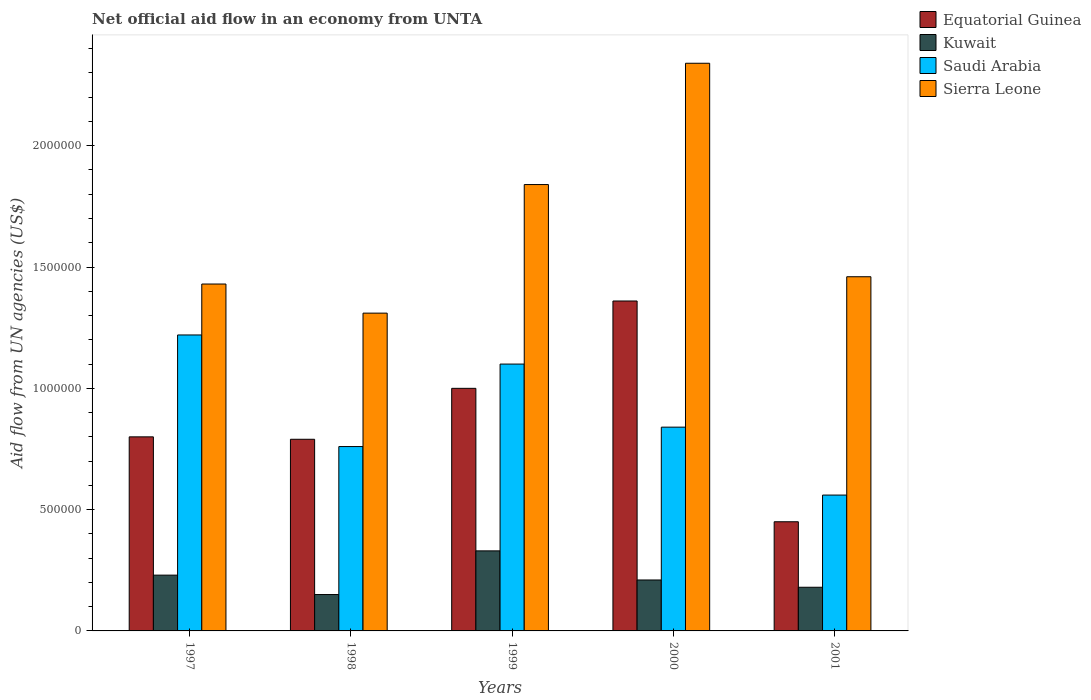How many groups of bars are there?
Ensure brevity in your answer.  5. Are the number of bars per tick equal to the number of legend labels?
Your answer should be very brief. Yes. How many bars are there on the 2nd tick from the left?
Give a very brief answer. 4. How many bars are there on the 2nd tick from the right?
Your response must be concise. 4. What is the label of the 5th group of bars from the left?
Your answer should be compact. 2001. In how many cases, is the number of bars for a given year not equal to the number of legend labels?
Keep it short and to the point. 0. Across all years, what is the maximum net official aid flow in Sierra Leone?
Give a very brief answer. 2.34e+06. Across all years, what is the minimum net official aid flow in Kuwait?
Provide a short and direct response. 1.50e+05. In which year was the net official aid flow in Sierra Leone maximum?
Keep it short and to the point. 2000. What is the total net official aid flow in Sierra Leone in the graph?
Keep it short and to the point. 8.38e+06. What is the difference between the net official aid flow in Sierra Leone in 1997 and that in 1999?
Offer a terse response. -4.10e+05. What is the difference between the net official aid flow in Sierra Leone in 1997 and the net official aid flow in Kuwait in 2001?
Ensure brevity in your answer.  1.25e+06. What is the ratio of the net official aid flow in Equatorial Guinea in 1997 to that in 1999?
Offer a terse response. 0.8. Is the difference between the net official aid flow in Sierra Leone in 1997 and 2000 greater than the difference between the net official aid flow in Saudi Arabia in 1997 and 2000?
Your response must be concise. No. What is the difference between the highest and the second highest net official aid flow in Equatorial Guinea?
Provide a short and direct response. 3.60e+05. What is the difference between the highest and the lowest net official aid flow in Sierra Leone?
Provide a succinct answer. 1.03e+06. In how many years, is the net official aid flow in Saudi Arabia greater than the average net official aid flow in Saudi Arabia taken over all years?
Keep it short and to the point. 2. What does the 3rd bar from the left in 2000 represents?
Your answer should be very brief. Saudi Arabia. What does the 2nd bar from the right in 2001 represents?
Make the answer very short. Saudi Arabia. Is it the case that in every year, the sum of the net official aid flow in Kuwait and net official aid flow in Sierra Leone is greater than the net official aid flow in Saudi Arabia?
Offer a very short reply. Yes. Where does the legend appear in the graph?
Your answer should be compact. Top right. How are the legend labels stacked?
Provide a succinct answer. Vertical. What is the title of the graph?
Provide a short and direct response. Net official aid flow in an economy from UNTA. Does "Other small states" appear as one of the legend labels in the graph?
Give a very brief answer. No. What is the label or title of the X-axis?
Make the answer very short. Years. What is the label or title of the Y-axis?
Make the answer very short. Aid flow from UN agencies (US$). What is the Aid flow from UN agencies (US$) in Equatorial Guinea in 1997?
Keep it short and to the point. 8.00e+05. What is the Aid flow from UN agencies (US$) in Saudi Arabia in 1997?
Give a very brief answer. 1.22e+06. What is the Aid flow from UN agencies (US$) of Sierra Leone in 1997?
Offer a terse response. 1.43e+06. What is the Aid flow from UN agencies (US$) in Equatorial Guinea in 1998?
Provide a succinct answer. 7.90e+05. What is the Aid flow from UN agencies (US$) in Saudi Arabia in 1998?
Your answer should be compact. 7.60e+05. What is the Aid flow from UN agencies (US$) of Sierra Leone in 1998?
Give a very brief answer. 1.31e+06. What is the Aid flow from UN agencies (US$) in Equatorial Guinea in 1999?
Your answer should be compact. 1.00e+06. What is the Aid flow from UN agencies (US$) of Saudi Arabia in 1999?
Your answer should be compact. 1.10e+06. What is the Aid flow from UN agencies (US$) in Sierra Leone in 1999?
Offer a terse response. 1.84e+06. What is the Aid flow from UN agencies (US$) in Equatorial Guinea in 2000?
Offer a very short reply. 1.36e+06. What is the Aid flow from UN agencies (US$) of Kuwait in 2000?
Make the answer very short. 2.10e+05. What is the Aid flow from UN agencies (US$) in Saudi Arabia in 2000?
Your response must be concise. 8.40e+05. What is the Aid flow from UN agencies (US$) in Sierra Leone in 2000?
Ensure brevity in your answer.  2.34e+06. What is the Aid flow from UN agencies (US$) of Kuwait in 2001?
Your response must be concise. 1.80e+05. What is the Aid flow from UN agencies (US$) of Saudi Arabia in 2001?
Provide a succinct answer. 5.60e+05. What is the Aid flow from UN agencies (US$) of Sierra Leone in 2001?
Offer a terse response. 1.46e+06. Across all years, what is the maximum Aid flow from UN agencies (US$) in Equatorial Guinea?
Make the answer very short. 1.36e+06. Across all years, what is the maximum Aid flow from UN agencies (US$) of Saudi Arabia?
Provide a short and direct response. 1.22e+06. Across all years, what is the maximum Aid flow from UN agencies (US$) in Sierra Leone?
Your answer should be compact. 2.34e+06. Across all years, what is the minimum Aid flow from UN agencies (US$) of Equatorial Guinea?
Your response must be concise. 4.50e+05. Across all years, what is the minimum Aid flow from UN agencies (US$) in Kuwait?
Your response must be concise. 1.50e+05. Across all years, what is the minimum Aid flow from UN agencies (US$) in Saudi Arabia?
Keep it short and to the point. 5.60e+05. Across all years, what is the minimum Aid flow from UN agencies (US$) of Sierra Leone?
Make the answer very short. 1.31e+06. What is the total Aid flow from UN agencies (US$) of Equatorial Guinea in the graph?
Offer a terse response. 4.40e+06. What is the total Aid flow from UN agencies (US$) of Kuwait in the graph?
Provide a short and direct response. 1.10e+06. What is the total Aid flow from UN agencies (US$) of Saudi Arabia in the graph?
Your answer should be very brief. 4.48e+06. What is the total Aid flow from UN agencies (US$) of Sierra Leone in the graph?
Ensure brevity in your answer.  8.38e+06. What is the difference between the Aid flow from UN agencies (US$) of Kuwait in 1997 and that in 1998?
Your response must be concise. 8.00e+04. What is the difference between the Aid flow from UN agencies (US$) in Saudi Arabia in 1997 and that in 1998?
Your answer should be compact. 4.60e+05. What is the difference between the Aid flow from UN agencies (US$) in Sierra Leone in 1997 and that in 1998?
Ensure brevity in your answer.  1.20e+05. What is the difference between the Aid flow from UN agencies (US$) in Equatorial Guinea in 1997 and that in 1999?
Provide a short and direct response. -2.00e+05. What is the difference between the Aid flow from UN agencies (US$) of Kuwait in 1997 and that in 1999?
Ensure brevity in your answer.  -1.00e+05. What is the difference between the Aid flow from UN agencies (US$) of Saudi Arabia in 1997 and that in 1999?
Give a very brief answer. 1.20e+05. What is the difference between the Aid flow from UN agencies (US$) of Sierra Leone in 1997 and that in 1999?
Your response must be concise. -4.10e+05. What is the difference between the Aid flow from UN agencies (US$) in Equatorial Guinea in 1997 and that in 2000?
Offer a terse response. -5.60e+05. What is the difference between the Aid flow from UN agencies (US$) in Sierra Leone in 1997 and that in 2000?
Your answer should be very brief. -9.10e+05. What is the difference between the Aid flow from UN agencies (US$) of Equatorial Guinea in 1997 and that in 2001?
Ensure brevity in your answer.  3.50e+05. What is the difference between the Aid flow from UN agencies (US$) in Kuwait in 1997 and that in 2001?
Make the answer very short. 5.00e+04. What is the difference between the Aid flow from UN agencies (US$) of Saudi Arabia in 1997 and that in 2001?
Offer a terse response. 6.60e+05. What is the difference between the Aid flow from UN agencies (US$) of Kuwait in 1998 and that in 1999?
Your response must be concise. -1.80e+05. What is the difference between the Aid flow from UN agencies (US$) in Saudi Arabia in 1998 and that in 1999?
Your answer should be compact. -3.40e+05. What is the difference between the Aid flow from UN agencies (US$) of Sierra Leone in 1998 and that in 1999?
Offer a very short reply. -5.30e+05. What is the difference between the Aid flow from UN agencies (US$) in Equatorial Guinea in 1998 and that in 2000?
Provide a succinct answer. -5.70e+05. What is the difference between the Aid flow from UN agencies (US$) of Kuwait in 1998 and that in 2000?
Your answer should be compact. -6.00e+04. What is the difference between the Aid flow from UN agencies (US$) in Saudi Arabia in 1998 and that in 2000?
Give a very brief answer. -8.00e+04. What is the difference between the Aid flow from UN agencies (US$) of Sierra Leone in 1998 and that in 2000?
Offer a very short reply. -1.03e+06. What is the difference between the Aid flow from UN agencies (US$) of Equatorial Guinea in 1998 and that in 2001?
Your answer should be compact. 3.40e+05. What is the difference between the Aid flow from UN agencies (US$) in Kuwait in 1998 and that in 2001?
Give a very brief answer. -3.00e+04. What is the difference between the Aid flow from UN agencies (US$) in Saudi Arabia in 1998 and that in 2001?
Give a very brief answer. 2.00e+05. What is the difference between the Aid flow from UN agencies (US$) in Equatorial Guinea in 1999 and that in 2000?
Keep it short and to the point. -3.60e+05. What is the difference between the Aid flow from UN agencies (US$) in Saudi Arabia in 1999 and that in 2000?
Make the answer very short. 2.60e+05. What is the difference between the Aid flow from UN agencies (US$) of Sierra Leone in 1999 and that in 2000?
Keep it short and to the point. -5.00e+05. What is the difference between the Aid flow from UN agencies (US$) of Saudi Arabia in 1999 and that in 2001?
Offer a very short reply. 5.40e+05. What is the difference between the Aid flow from UN agencies (US$) of Equatorial Guinea in 2000 and that in 2001?
Ensure brevity in your answer.  9.10e+05. What is the difference between the Aid flow from UN agencies (US$) in Sierra Leone in 2000 and that in 2001?
Give a very brief answer. 8.80e+05. What is the difference between the Aid flow from UN agencies (US$) of Equatorial Guinea in 1997 and the Aid flow from UN agencies (US$) of Kuwait in 1998?
Keep it short and to the point. 6.50e+05. What is the difference between the Aid flow from UN agencies (US$) of Equatorial Guinea in 1997 and the Aid flow from UN agencies (US$) of Sierra Leone in 1998?
Ensure brevity in your answer.  -5.10e+05. What is the difference between the Aid flow from UN agencies (US$) of Kuwait in 1997 and the Aid flow from UN agencies (US$) of Saudi Arabia in 1998?
Offer a terse response. -5.30e+05. What is the difference between the Aid flow from UN agencies (US$) of Kuwait in 1997 and the Aid flow from UN agencies (US$) of Sierra Leone in 1998?
Provide a short and direct response. -1.08e+06. What is the difference between the Aid flow from UN agencies (US$) of Saudi Arabia in 1997 and the Aid flow from UN agencies (US$) of Sierra Leone in 1998?
Your answer should be compact. -9.00e+04. What is the difference between the Aid flow from UN agencies (US$) of Equatorial Guinea in 1997 and the Aid flow from UN agencies (US$) of Kuwait in 1999?
Make the answer very short. 4.70e+05. What is the difference between the Aid flow from UN agencies (US$) in Equatorial Guinea in 1997 and the Aid flow from UN agencies (US$) in Saudi Arabia in 1999?
Provide a succinct answer. -3.00e+05. What is the difference between the Aid flow from UN agencies (US$) of Equatorial Guinea in 1997 and the Aid flow from UN agencies (US$) of Sierra Leone in 1999?
Provide a succinct answer. -1.04e+06. What is the difference between the Aid flow from UN agencies (US$) in Kuwait in 1997 and the Aid flow from UN agencies (US$) in Saudi Arabia in 1999?
Offer a very short reply. -8.70e+05. What is the difference between the Aid flow from UN agencies (US$) in Kuwait in 1997 and the Aid flow from UN agencies (US$) in Sierra Leone in 1999?
Provide a short and direct response. -1.61e+06. What is the difference between the Aid flow from UN agencies (US$) of Saudi Arabia in 1997 and the Aid flow from UN agencies (US$) of Sierra Leone in 1999?
Offer a very short reply. -6.20e+05. What is the difference between the Aid flow from UN agencies (US$) of Equatorial Guinea in 1997 and the Aid flow from UN agencies (US$) of Kuwait in 2000?
Offer a very short reply. 5.90e+05. What is the difference between the Aid flow from UN agencies (US$) in Equatorial Guinea in 1997 and the Aid flow from UN agencies (US$) in Saudi Arabia in 2000?
Provide a short and direct response. -4.00e+04. What is the difference between the Aid flow from UN agencies (US$) in Equatorial Guinea in 1997 and the Aid flow from UN agencies (US$) in Sierra Leone in 2000?
Your answer should be very brief. -1.54e+06. What is the difference between the Aid flow from UN agencies (US$) of Kuwait in 1997 and the Aid flow from UN agencies (US$) of Saudi Arabia in 2000?
Ensure brevity in your answer.  -6.10e+05. What is the difference between the Aid flow from UN agencies (US$) in Kuwait in 1997 and the Aid flow from UN agencies (US$) in Sierra Leone in 2000?
Give a very brief answer. -2.11e+06. What is the difference between the Aid flow from UN agencies (US$) in Saudi Arabia in 1997 and the Aid flow from UN agencies (US$) in Sierra Leone in 2000?
Offer a very short reply. -1.12e+06. What is the difference between the Aid flow from UN agencies (US$) in Equatorial Guinea in 1997 and the Aid flow from UN agencies (US$) in Kuwait in 2001?
Ensure brevity in your answer.  6.20e+05. What is the difference between the Aid flow from UN agencies (US$) of Equatorial Guinea in 1997 and the Aid flow from UN agencies (US$) of Sierra Leone in 2001?
Your answer should be very brief. -6.60e+05. What is the difference between the Aid flow from UN agencies (US$) in Kuwait in 1997 and the Aid flow from UN agencies (US$) in Saudi Arabia in 2001?
Provide a succinct answer. -3.30e+05. What is the difference between the Aid flow from UN agencies (US$) in Kuwait in 1997 and the Aid flow from UN agencies (US$) in Sierra Leone in 2001?
Your response must be concise. -1.23e+06. What is the difference between the Aid flow from UN agencies (US$) of Saudi Arabia in 1997 and the Aid flow from UN agencies (US$) of Sierra Leone in 2001?
Offer a terse response. -2.40e+05. What is the difference between the Aid flow from UN agencies (US$) of Equatorial Guinea in 1998 and the Aid flow from UN agencies (US$) of Saudi Arabia in 1999?
Ensure brevity in your answer.  -3.10e+05. What is the difference between the Aid flow from UN agencies (US$) in Equatorial Guinea in 1998 and the Aid flow from UN agencies (US$) in Sierra Leone in 1999?
Your response must be concise. -1.05e+06. What is the difference between the Aid flow from UN agencies (US$) of Kuwait in 1998 and the Aid flow from UN agencies (US$) of Saudi Arabia in 1999?
Provide a succinct answer. -9.50e+05. What is the difference between the Aid flow from UN agencies (US$) of Kuwait in 1998 and the Aid flow from UN agencies (US$) of Sierra Leone in 1999?
Your answer should be compact. -1.69e+06. What is the difference between the Aid flow from UN agencies (US$) of Saudi Arabia in 1998 and the Aid flow from UN agencies (US$) of Sierra Leone in 1999?
Provide a succinct answer. -1.08e+06. What is the difference between the Aid flow from UN agencies (US$) of Equatorial Guinea in 1998 and the Aid flow from UN agencies (US$) of Kuwait in 2000?
Your answer should be compact. 5.80e+05. What is the difference between the Aid flow from UN agencies (US$) in Equatorial Guinea in 1998 and the Aid flow from UN agencies (US$) in Sierra Leone in 2000?
Ensure brevity in your answer.  -1.55e+06. What is the difference between the Aid flow from UN agencies (US$) of Kuwait in 1998 and the Aid flow from UN agencies (US$) of Saudi Arabia in 2000?
Make the answer very short. -6.90e+05. What is the difference between the Aid flow from UN agencies (US$) in Kuwait in 1998 and the Aid flow from UN agencies (US$) in Sierra Leone in 2000?
Give a very brief answer. -2.19e+06. What is the difference between the Aid flow from UN agencies (US$) in Saudi Arabia in 1998 and the Aid flow from UN agencies (US$) in Sierra Leone in 2000?
Provide a short and direct response. -1.58e+06. What is the difference between the Aid flow from UN agencies (US$) in Equatorial Guinea in 1998 and the Aid flow from UN agencies (US$) in Sierra Leone in 2001?
Make the answer very short. -6.70e+05. What is the difference between the Aid flow from UN agencies (US$) in Kuwait in 1998 and the Aid flow from UN agencies (US$) in Saudi Arabia in 2001?
Offer a very short reply. -4.10e+05. What is the difference between the Aid flow from UN agencies (US$) of Kuwait in 1998 and the Aid flow from UN agencies (US$) of Sierra Leone in 2001?
Offer a very short reply. -1.31e+06. What is the difference between the Aid flow from UN agencies (US$) of Saudi Arabia in 1998 and the Aid flow from UN agencies (US$) of Sierra Leone in 2001?
Provide a short and direct response. -7.00e+05. What is the difference between the Aid flow from UN agencies (US$) of Equatorial Guinea in 1999 and the Aid flow from UN agencies (US$) of Kuwait in 2000?
Your response must be concise. 7.90e+05. What is the difference between the Aid flow from UN agencies (US$) in Equatorial Guinea in 1999 and the Aid flow from UN agencies (US$) in Saudi Arabia in 2000?
Provide a succinct answer. 1.60e+05. What is the difference between the Aid flow from UN agencies (US$) in Equatorial Guinea in 1999 and the Aid flow from UN agencies (US$) in Sierra Leone in 2000?
Offer a very short reply. -1.34e+06. What is the difference between the Aid flow from UN agencies (US$) of Kuwait in 1999 and the Aid flow from UN agencies (US$) of Saudi Arabia in 2000?
Your answer should be compact. -5.10e+05. What is the difference between the Aid flow from UN agencies (US$) in Kuwait in 1999 and the Aid flow from UN agencies (US$) in Sierra Leone in 2000?
Your answer should be compact. -2.01e+06. What is the difference between the Aid flow from UN agencies (US$) of Saudi Arabia in 1999 and the Aid flow from UN agencies (US$) of Sierra Leone in 2000?
Offer a terse response. -1.24e+06. What is the difference between the Aid flow from UN agencies (US$) in Equatorial Guinea in 1999 and the Aid flow from UN agencies (US$) in Kuwait in 2001?
Provide a short and direct response. 8.20e+05. What is the difference between the Aid flow from UN agencies (US$) in Equatorial Guinea in 1999 and the Aid flow from UN agencies (US$) in Saudi Arabia in 2001?
Provide a short and direct response. 4.40e+05. What is the difference between the Aid flow from UN agencies (US$) in Equatorial Guinea in 1999 and the Aid flow from UN agencies (US$) in Sierra Leone in 2001?
Provide a succinct answer. -4.60e+05. What is the difference between the Aid flow from UN agencies (US$) in Kuwait in 1999 and the Aid flow from UN agencies (US$) in Sierra Leone in 2001?
Provide a succinct answer. -1.13e+06. What is the difference between the Aid flow from UN agencies (US$) of Saudi Arabia in 1999 and the Aid flow from UN agencies (US$) of Sierra Leone in 2001?
Provide a succinct answer. -3.60e+05. What is the difference between the Aid flow from UN agencies (US$) in Equatorial Guinea in 2000 and the Aid flow from UN agencies (US$) in Kuwait in 2001?
Your answer should be very brief. 1.18e+06. What is the difference between the Aid flow from UN agencies (US$) of Equatorial Guinea in 2000 and the Aid flow from UN agencies (US$) of Sierra Leone in 2001?
Give a very brief answer. -1.00e+05. What is the difference between the Aid flow from UN agencies (US$) in Kuwait in 2000 and the Aid flow from UN agencies (US$) in Saudi Arabia in 2001?
Your answer should be very brief. -3.50e+05. What is the difference between the Aid flow from UN agencies (US$) in Kuwait in 2000 and the Aid flow from UN agencies (US$) in Sierra Leone in 2001?
Keep it short and to the point. -1.25e+06. What is the difference between the Aid flow from UN agencies (US$) in Saudi Arabia in 2000 and the Aid flow from UN agencies (US$) in Sierra Leone in 2001?
Your answer should be very brief. -6.20e+05. What is the average Aid flow from UN agencies (US$) in Equatorial Guinea per year?
Offer a very short reply. 8.80e+05. What is the average Aid flow from UN agencies (US$) of Saudi Arabia per year?
Give a very brief answer. 8.96e+05. What is the average Aid flow from UN agencies (US$) of Sierra Leone per year?
Ensure brevity in your answer.  1.68e+06. In the year 1997, what is the difference between the Aid flow from UN agencies (US$) in Equatorial Guinea and Aid flow from UN agencies (US$) in Kuwait?
Provide a succinct answer. 5.70e+05. In the year 1997, what is the difference between the Aid flow from UN agencies (US$) in Equatorial Guinea and Aid flow from UN agencies (US$) in Saudi Arabia?
Give a very brief answer. -4.20e+05. In the year 1997, what is the difference between the Aid flow from UN agencies (US$) in Equatorial Guinea and Aid flow from UN agencies (US$) in Sierra Leone?
Your answer should be very brief. -6.30e+05. In the year 1997, what is the difference between the Aid flow from UN agencies (US$) in Kuwait and Aid flow from UN agencies (US$) in Saudi Arabia?
Your response must be concise. -9.90e+05. In the year 1997, what is the difference between the Aid flow from UN agencies (US$) of Kuwait and Aid flow from UN agencies (US$) of Sierra Leone?
Offer a terse response. -1.20e+06. In the year 1997, what is the difference between the Aid flow from UN agencies (US$) in Saudi Arabia and Aid flow from UN agencies (US$) in Sierra Leone?
Give a very brief answer. -2.10e+05. In the year 1998, what is the difference between the Aid flow from UN agencies (US$) of Equatorial Guinea and Aid flow from UN agencies (US$) of Kuwait?
Keep it short and to the point. 6.40e+05. In the year 1998, what is the difference between the Aid flow from UN agencies (US$) of Equatorial Guinea and Aid flow from UN agencies (US$) of Saudi Arabia?
Ensure brevity in your answer.  3.00e+04. In the year 1998, what is the difference between the Aid flow from UN agencies (US$) in Equatorial Guinea and Aid flow from UN agencies (US$) in Sierra Leone?
Provide a short and direct response. -5.20e+05. In the year 1998, what is the difference between the Aid flow from UN agencies (US$) of Kuwait and Aid flow from UN agencies (US$) of Saudi Arabia?
Your response must be concise. -6.10e+05. In the year 1998, what is the difference between the Aid flow from UN agencies (US$) in Kuwait and Aid flow from UN agencies (US$) in Sierra Leone?
Provide a succinct answer. -1.16e+06. In the year 1998, what is the difference between the Aid flow from UN agencies (US$) of Saudi Arabia and Aid flow from UN agencies (US$) of Sierra Leone?
Give a very brief answer. -5.50e+05. In the year 1999, what is the difference between the Aid flow from UN agencies (US$) of Equatorial Guinea and Aid flow from UN agencies (US$) of Kuwait?
Offer a very short reply. 6.70e+05. In the year 1999, what is the difference between the Aid flow from UN agencies (US$) in Equatorial Guinea and Aid flow from UN agencies (US$) in Saudi Arabia?
Your response must be concise. -1.00e+05. In the year 1999, what is the difference between the Aid flow from UN agencies (US$) of Equatorial Guinea and Aid flow from UN agencies (US$) of Sierra Leone?
Your answer should be compact. -8.40e+05. In the year 1999, what is the difference between the Aid flow from UN agencies (US$) of Kuwait and Aid flow from UN agencies (US$) of Saudi Arabia?
Ensure brevity in your answer.  -7.70e+05. In the year 1999, what is the difference between the Aid flow from UN agencies (US$) in Kuwait and Aid flow from UN agencies (US$) in Sierra Leone?
Your answer should be very brief. -1.51e+06. In the year 1999, what is the difference between the Aid flow from UN agencies (US$) in Saudi Arabia and Aid flow from UN agencies (US$) in Sierra Leone?
Provide a succinct answer. -7.40e+05. In the year 2000, what is the difference between the Aid flow from UN agencies (US$) in Equatorial Guinea and Aid flow from UN agencies (US$) in Kuwait?
Keep it short and to the point. 1.15e+06. In the year 2000, what is the difference between the Aid flow from UN agencies (US$) of Equatorial Guinea and Aid flow from UN agencies (US$) of Saudi Arabia?
Ensure brevity in your answer.  5.20e+05. In the year 2000, what is the difference between the Aid flow from UN agencies (US$) of Equatorial Guinea and Aid flow from UN agencies (US$) of Sierra Leone?
Give a very brief answer. -9.80e+05. In the year 2000, what is the difference between the Aid flow from UN agencies (US$) of Kuwait and Aid flow from UN agencies (US$) of Saudi Arabia?
Offer a terse response. -6.30e+05. In the year 2000, what is the difference between the Aid flow from UN agencies (US$) in Kuwait and Aid flow from UN agencies (US$) in Sierra Leone?
Provide a succinct answer. -2.13e+06. In the year 2000, what is the difference between the Aid flow from UN agencies (US$) in Saudi Arabia and Aid flow from UN agencies (US$) in Sierra Leone?
Ensure brevity in your answer.  -1.50e+06. In the year 2001, what is the difference between the Aid flow from UN agencies (US$) in Equatorial Guinea and Aid flow from UN agencies (US$) in Saudi Arabia?
Your answer should be very brief. -1.10e+05. In the year 2001, what is the difference between the Aid flow from UN agencies (US$) of Equatorial Guinea and Aid flow from UN agencies (US$) of Sierra Leone?
Offer a terse response. -1.01e+06. In the year 2001, what is the difference between the Aid flow from UN agencies (US$) in Kuwait and Aid flow from UN agencies (US$) in Saudi Arabia?
Offer a terse response. -3.80e+05. In the year 2001, what is the difference between the Aid flow from UN agencies (US$) of Kuwait and Aid flow from UN agencies (US$) of Sierra Leone?
Provide a short and direct response. -1.28e+06. In the year 2001, what is the difference between the Aid flow from UN agencies (US$) of Saudi Arabia and Aid flow from UN agencies (US$) of Sierra Leone?
Provide a short and direct response. -9.00e+05. What is the ratio of the Aid flow from UN agencies (US$) in Equatorial Guinea in 1997 to that in 1998?
Your answer should be very brief. 1.01. What is the ratio of the Aid flow from UN agencies (US$) of Kuwait in 1997 to that in 1998?
Provide a succinct answer. 1.53. What is the ratio of the Aid flow from UN agencies (US$) in Saudi Arabia in 1997 to that in 1998?
Keep it short and to the point. 1.61. What is the ratio of the Aid flow from UN agencies (US$) in Sierra Leone in 1997 to that in 1998?
Keep it short and to the point. 1.09. What is the ratio of the Aid flow from UN agencies (US$) in Kuwait in 1997 to that in 1999?
Your answer should be compact. 0.7. What is the ratio of the Aid flow from UN agencies (US$) of Saudi Arabia in 1997 to that in 1999?
Make the answer very short. 1.11. What is the ratio of the Aid flow from UN agencies (US$) in Sierra Leone in 1997 to that in 1999?
Provide a short and direct response. 0.78. What is the ratio of the Aid flow from UN agencies (US$) of Equatorial Guinea in 1997 to that in 2000?
Give a very brief answer. 0.59. What is the ratio of the Aid flow from UN agencies (US$) of Kuwait in 1997 to that in 2000?
Offer a terse response. 1.1. What is the ratio of the Aid flow from UN agencies (US$) in Saudi Arabia in 1997 to that in 2000?
Keep it short and to the point. 1.45. What is the ratio of the Aid flow from UN agencies (US$) in Sierra Leone in 1997 to that in 2000?
Keep it short and to the point. 0.61. What is the ratio of the Aid flow from UN agencies (US$) of Equatorial Guinea in 1997 to that in 2001?
Provide a succinct answer. 1.78. What is the ratio of the Aid flow from UN agencies (US$) in Kuwait in 1997 to that in 2001?
Provide a succinct answer. 1.28. What is the ratio of the Aid flow from UN agencies (US$) in Saudi Arabia in 1997 to that in 2001?
Your answer should be compact. 2.18. What is the ratio of the Aid flow from UN agencies (US$) of Sierra Leone in 1997 to that in 2001?
Give a very brief answer. 0.98. What is the ratio of the Aid flow from UN agencies (US$) of Equatorial Guinea in 1998 to that in 1999?
Offer a terse response. 0.79. What is the ratio of the Aid flow from UN agencies (US$) in Kuwait in 1998 to that in 1999?
Offer a very short reply. 0.45. What is the ratio of the Aid flow from UN agencies (US$) in Saudi Arabia in 1998 to that in 1999?
Offer a terse response. 0.69. What is the ratio of the Aid flow from UN agencies (US$) of Sierra Leone in 1998 to that in 1999?
Make the answer very short. 0.71. What is the ratio of the Aid flow from UN agencies (US$) in Equatorial Guinea in 1998 to that in 2000?
Your response must be concise. 0.58. What is the ratio of the Aid flow from UN agencies (US$) of Saudi Arabia in 1998 to that in 2000?
Your answer should be very brief. 0.9. What is the ratio of the Aid flow from UN agencies (US$) in Sierra Leone in 1998 to that in 2000?
Keep it short and to the point. 0.56. What is the ratio of the Aid flow from UN agencies (US$) in Equatorial Guinea in 1998 to that in 2001?
Offer a very short reply. 1.76. What is the ratio of the Aid flow from UN agencies (US$) in Saudi Arabia in 1998 to that in 2001?
Your answer should be very brief. 1.36. What is the ratio of the Aid flow from UN agencies (US$) in Sierra Leone in 1998 to that in 2001?
Your response must be concise. 0.9. What is the ratio of the Aid flow from UN agencies (US$) of Equatorial Guinea in 1999 to that in 2000?
Provide a short and direct response. 0.74. What is the ratio of the Aid flow from UN agencies (US$) of Kuwait in 1999 to that in 2000?
Provide a short and direct response. 1.57. What is the ratio of the Aid flow from UN agencies (US$) of Saudi Arabia in 1999 to that in 2000?
Provide a succinct answer. 1.31. What is the ratio of the Aid flow from UN agencies (US$) of Sierra Leone in 1999 to that in 2000?
Offer a very short reply. 0.79. What is the ratio of the Aid flow from UN agencies (US$) in Equatorial Guinea in 1999 to that in 2001?
Your response must be concise. 2.22. What is the ratio of the Aid flow from UN agencies (US$) of Kuwait in 1999 to that in 2001?
Your answer should be compact. 1.83. What is the ratio of the Aid flow from UN agencies (US$) in Saudi Arabia in 1999 to that in 2001?
Give a very brief answer. 1.96. What is the ratio of the Aid flow from UN agencies (US$) in Sierra Leone in 1999 to that in 2001?
Your answer should be compact. 1.26. What is the ratio of the Aid flow from UN agencies (US$) in Equatorial Guinea in 2000 to that in 2001?
Make the answer very short. 3.02. What is the ratio of the Aid flow from UN agencies (US$) in Kuwait in 2000 to that in 2001?
Your answer should be compact. 1.17. What is the ratio of the Aid flow from UN agencies (US$) of Saudi Arabia in 2000 to that in 2001?
Offer a very short reply. 1.5. What is the ratio of the Aid flow from UN agencies (US$) of Sierra Leone in 2000 to that in 2001?
Your response must be concise. 1.6. What is the difference between the highest and the second highest Aid flow from UN agencies (US$) of Equatorial Guinea?
Provide a succinct answer. 3.60e+05. What is the difference between the highest and the second highest Aid flow from UN agencies (US$) of Kuwait?
Offer a terse response. 1.00e+05. What is the difference between the highest and the second highest Aid flow from UN agencies (US$) in Sierra Leone?
Make the answer very short. 5.00e+05. What is the difference between the highest and the lowest Aid flow from UN agencies (US$) in Equatorial Guinea?
Your answer should be compact. 9.10e+05. What is the difference between the highest and the lowest Aid flow from UN agencies (US$) in Kuwait?
Your answer should be very brief. 1.80e+05. What is the difference between the highest and the lowest Aid flow from UN agencies (US$) of Sierra Leone?
Offer a terse response. 1.03e+06. 